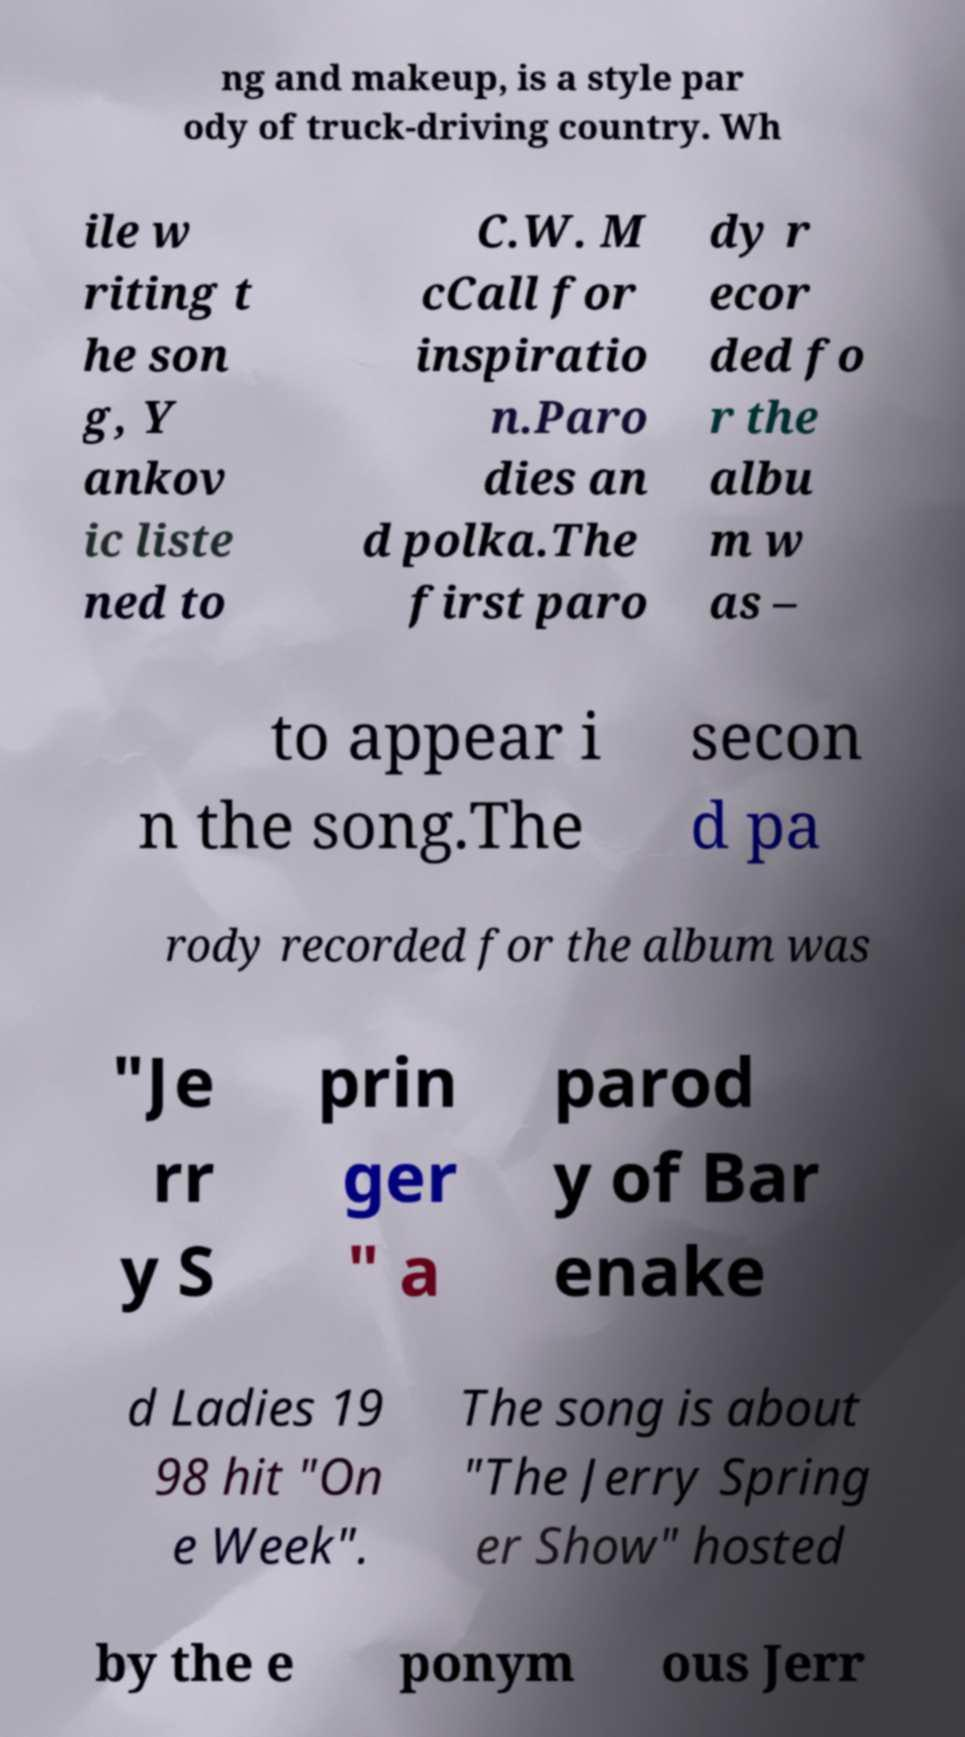There's text embedded in this image that I need extracted. Can you transcribe it verbatim? ng and makeup, is a style par ody of truck-driving country. Wh ile w riting t he son g, Y ankov ic liste ned to C.W. M cCall for inspiratio n.Paro dies an d polka.The first paro dy r ecor ded fo r the albu m w as – to appear i n the song.The secon d pa rody recorded for the album was "Je rr y S prin ger " a parod y of Bar enake d Ladies 19 98 hit "On e Week". The song is about "The Jerry Spring er Show" hosted by the e ponym ous Jerr 